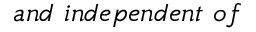Convert formula to latex. <formula><loc_0><loc_0><loc_500><loc_500>a n d \ i n d e p e n d e n t \ o f</formula> 